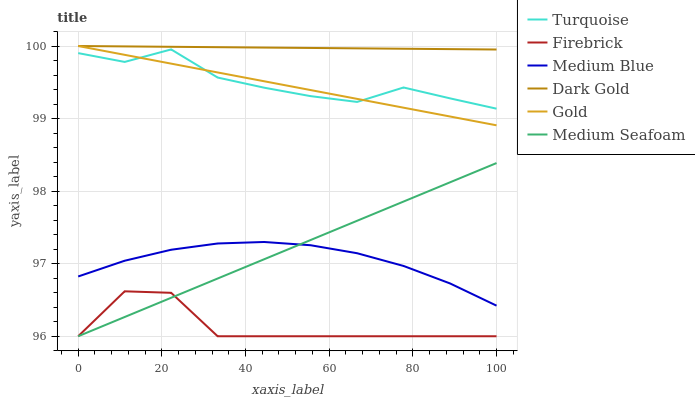Does Firebrick have the minimum area under the curve?
Answer yes or no. Yes. Does Dark Gold have the maximum area under the curve?
Answer yes or no. Yes. Does Gold have the minimum area under the curve?
Answer yes or no. No. Does Gold have the maximum area under the curve?
Answer yes or no. No. Is Gold the smoothest?
Answer yes or no. Yes. Is Firebrick the roughest?
Answer yes or no. Yes. Is Dark Gold the smoothest?
Answer yes or no. No. Is Dark Gold the roughest?
Answer yes or no. No. Does Firebrick have the lowest value?
Answer yes or no. Yes. Does Gold have the lowest value?
Answer yes or no. No. Does Dark Gold have the highest value?
Answer yes or no. Yes. Does Firebrick have the highest value?
Answer yes or no. No. Is Medium Seafoam less than Turquoise?
Answer yes or no. Yes. Is Dark Gold greater than Turquoise?
Answer yes or no. Yes. Does Medium Blue intersect Medium Seafoam?
Answer yes or no. Yes. Is Medium Blue less than Medium Seafoam?
Answer yes or no. No. Is Medium Blue greater than Medium Seafoam?
Answer yes or no. No. Does Medium Seafoam intersect Turquoise?
Answer yes or no. No. 